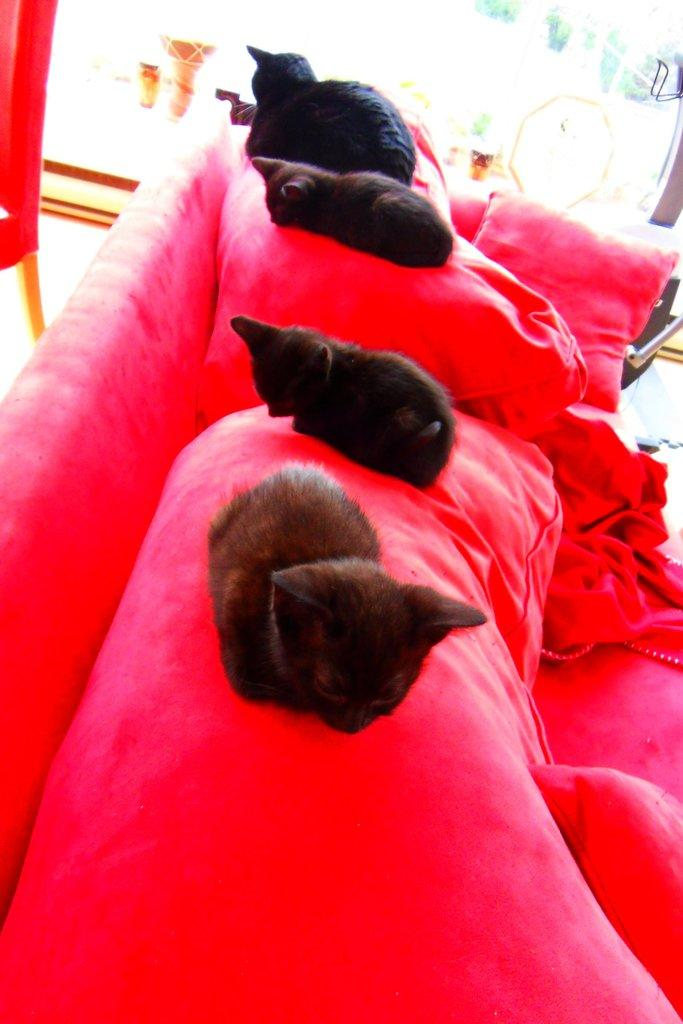What type of animals are in the image? There are cats in the image. What type of furniture or accessory can be seen in the image? There are pillows in the image. What architectural feature is visible in the background of the image? There is a door in the background of the image. Where is the bee located in the image? There is no bee present in the image. What type of playground equipment is visible in the image? There is no swing or any playground equipment present in the image. 